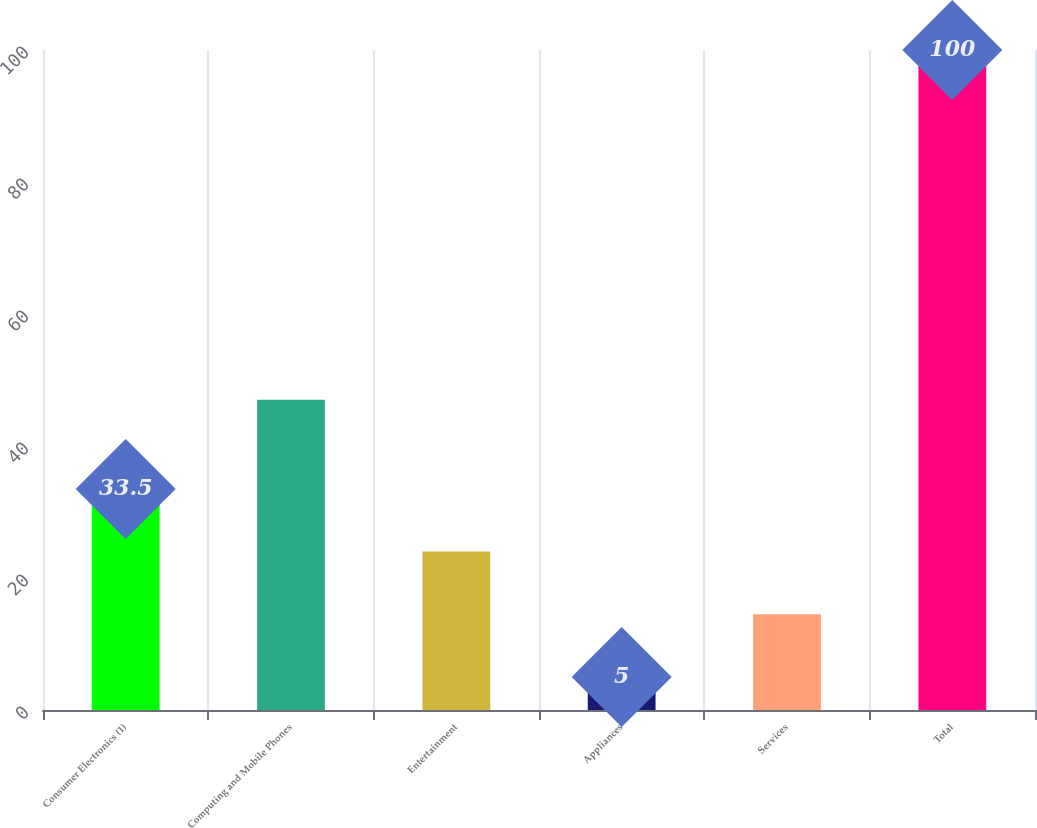Convert chart to OTSL. <chart><loc_0><loc_0><loc_500><loc_500><bar_chart><fcel>Consumer Electronics (1)<fcel>Computing and Mobile Phones<fcel>Entertainment<fcel>Appliances<fcel>Services<fcel>Total<nl><fcel>33.5<fcel>47<fcel>24<fcel>5<fcel>14.5<fcel>100<nl></chart> 